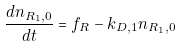<formula> <loc_0><loc_0><loc_500><loc_500>\frac { d n _ { R _ { 1 } , 0 } } { d t } = f _ { R } - k _ { D , 1 } n _ { R _ { 1 } , 0 }</formula> 